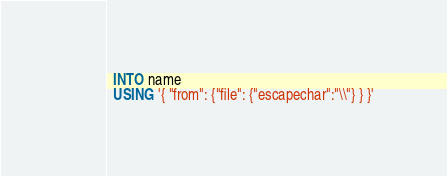<code> <loc_0><loc_0><loc_500><loc_500><_SQL_>  INTO name
  USING '{ "from": {"file": {"escapechar":"\\"} } }'
</code> 